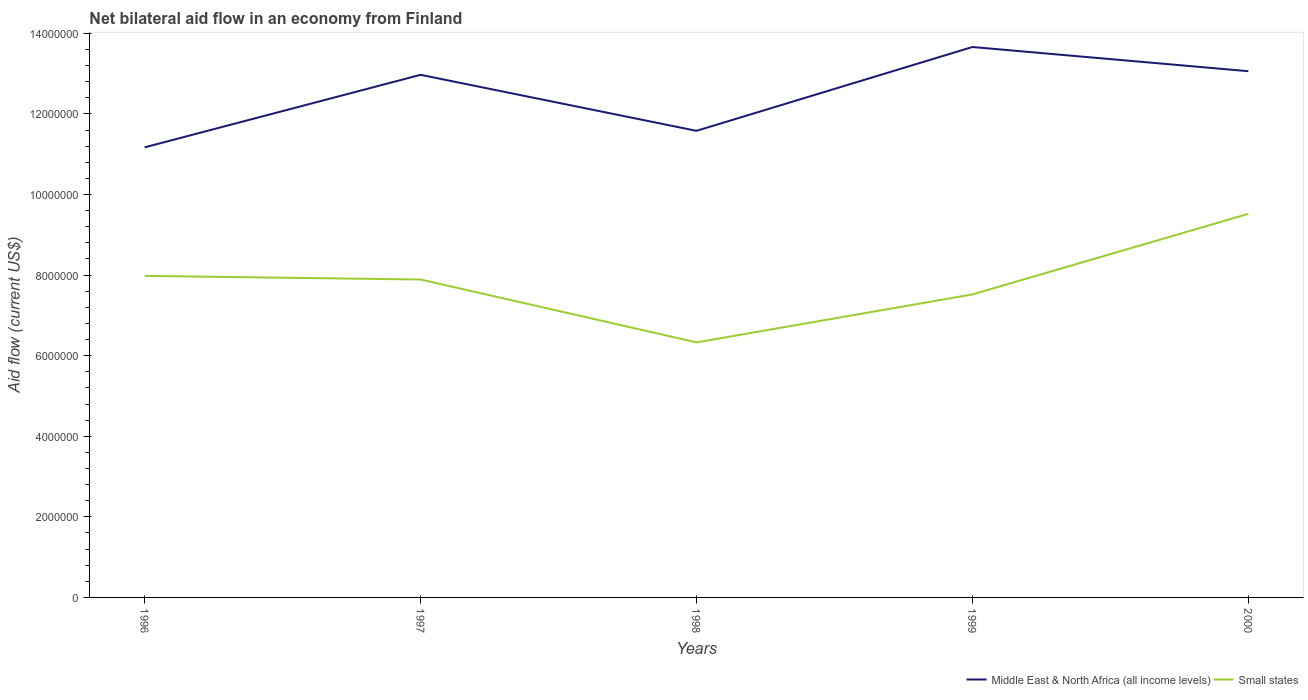Is the number of lines equal to the number of legend labels?
Keep it short and to the point. Yes. Across all years, what is the maximum net bilateral aid flow in Middle East & North Africa (all income levels)?
Make the answer very short. 1.12e+07. In which year was the net bilateral aid flow in Middle East & North Africa (all income levels) maximum?
Provide a short and direct response. 1996. What is the total net bilateral aid flow in Small states in the graph?
Your answer should be very brief. 1.56e+06. What is the difference between the highest and the second highest net bilateral aid flow in Middle East & North Africa (all income levels)?
Make the answer very short. 2.49e+06. What is the difference between the highest and the lowest net bilateral aid flow in Middle East & North Africa (all income levels)?
Offer a very short reply. 3. How many lines are there?
Give a very brief answer. 2. What is the difference between two consecutive major ticks on the Y-axis?
Give a very brief answer. 2.00e+06. Are the values on the major ticks of Y-axis written in scientific E-notation?
Your response must be concise. No. Where does the legend appear in the graph?
Ensure brevity in your answer.  Bottom right. How many legend labels are there?
Provide a short and direct response. 2. What is the title of the graph?
Provide a short and direct response. Net bilateral aid flow in an economy from Finland. Does "St. Kitts and Nevis" appear as one of the legend labels in the graph?
Ensure brevity in your answer.  No. What is the label or title of the X-axis?
Provide a succinct answer. Years. What is the label or title of the Y-axis?
Your response must be concise. Aid flow (current US$). What is the Aid flow (current US$) in Middle East & North Africa (all income levels) in 1996?
Offer a very short reply. 1.12e+07. What is the Aid flow (current US$) in Small states in 1996?
Your answer should be compact. 7.98e+06. What is the Aid flow (current US$) in Middle East & North Africa (all income levels) in 1997?
Give a very brief answer. 1.30e+07. What is the Aid flow (current US$) in Small states in 1997?
Make the answer very short. 7.89e+06. What is the Aid flow (current US$) in Middle East & North Africa (all income levels) in 1998?
Offer a terse response. 1.16e+07. What is the Aid flow (current US$) of Small states in 1998?
Offer a terse response. 6.33e+06. What is the Aid flow (current US$) in Middle East & North Africa (all income levels) in 1999?
Offer a terse response. 1.37e+07. What is the Aid flow (current US$) in Small states in 1999?
Your answer should be compact. 7.52e+06. What is the Aid flow (current US$) of Middle East & North Africa (all income levels) in 2000?
Offer a terse response. 1.31e+07. What is the Aid flow (current US$) of Small states in 2000?
Keep it short and to the point. 9.52e+06. Across all years, what is the maximum Aid flow (current US$) of Middle East & North Africa (all income levels)?
Give a very brief answer. 1.37e+07. Across all years, what is the maximum Aid flow (current US$) of Small states?
Provide a succinct answer. 9.52e+06. Across all years, what is the minimum Aid flow (current US$) in Middle East & North Africa (all income levels)?
Keep it short and to the point. 1.12e+07. Across all years, what is the minimum Aid flow (current US$) of Small states?
Your answer should be compact. 6.33e+06. What is the total Aid flow (current US$) of Middle East & North Africa (all income levels) in the graph?
Your answer should be very brief. 6.24e+07. What is the total Aid flow (current US$) of Small states in the graph?
Offer a terse response. 3.92e+07. What is the difference between the Aid flow (current US$) in Middle East & North Africa (all income levels) in 1996 and that in 1997?
Keep it short and to the point. -1.80e+06. What is the difference between the Aid flow (current US$) of Middle East & North Africa (all income levels) in 1996 and that in 1998?
Your answer should be very brief. -4.10e+05. What is the difference between the Aid flow (current US$) of Small states in 1996 and that in 1998?
Provide a succinct answer. 1.65e+06. What is the difference between the Aid flow (current US$) in Middle East & North Africa (all income levels) in 1996 and that in 1999?
Make the answer very short. -2.49e+06. What is the difference between the Aid flow (current US$) of Small states in 1996 and that in 1999?
Ensure brevity in your answer.  4.60e+05. What is the difference between the Aid flow (current US$) in Middle East & North Africa (all income levels) in 1996 and that in 2000?
Ensure brevity in your answer.  -1.89e+06. What is the difference between the Aid flow (current US$) of Small states in 1996 and that in 2000?
Your answer should be compact. -1.54e+06. What is the difference between the Aid flow (current US$) of Middle East & North Africa (all income levels) in 1997 and that in 1998?
Ensure brevity in your answer.  1.39e+06. What is the difference between the Aid flow (current US$) of Small states in 1997 and that in 1998?
Provide a succinct answer. 1.56e+06. What is the difference between the Aid flow (current US$) of Middle East & North Africa (all income levels) in 1997 and that in 1999?
Provide a succinct answer. -6.90e+05. What is the difference between the Aid flow (current US$) of Small states in 1997 and that in 1999?
Keep it short and to the point. 3.70e+05. What is the difference between the Aid flow (current US$) in Small states in 1997 and that in 2000?
Keep it short and to the point. -1.63e+06. What is the difference between the Aid flow (current US$) in Middle East & North Africa (all income levels) in 1998 and that in 1999?
Your response must be concise. -2.08e+06. What is the difference between the Aid flow (current US$) in Small states in 1998 and that in 1999?
Your response must be concise. -1.19e+06. What is the difference between the Aid flow (current US$) of Middle East & North Africa (all income levels) in 1998 and that in 2000?
Ensure brevity in your answer.  -1.48e+06. What is the difference between the Aid flow (current US$) of Small states in 1998 and that in 2000?
Your answer should be very brief. -3.19e+06. What is the difference between the Aid flow (current US$) in Small states in 1999 and that in 2000?
Provide a short and direct response. -2.00e+06. What is the difference between the Aid flow (current US$) in Middle East & North Africa (all income levels) in 1996 and the Aid flow (current US$) in Small states in 1997?
Provide a short and direct response. 3.28e+06. What is the difference between the Aid flow (current US$) of Middle East & North Africa (all income levels) in 1996 and the Aid flow (current US$) of Small states in 1998?
Provide a short and direct response. 4.84e+06. What is the difference between the Aid flow (current US$) of Middle East & North Africa (all income levels) in 1996 and the Aid flow (current US$) of Small states in 1999?
Your response must be concise. 3.65e+06. What is the difference between the Aid flow (current US$) in Middle East & North Africa (all income levels) in 1996 and the Aid flow (current US$) in Small states in 2000?
Keep it short and to the point. 1.65e+06. What is the difference between the Aid flow (current US$) in Middle East & North Africa (all income levels) in 1997 and the Aid flow (current US$) in Small states in 1998?
Provide a succinct answer. 6.64e+06. What is the difference between the Aid flow (current US$) of Middle East & North Africa (all income levels) in 1997 and the Aid flow (current US$) of Small states in 1999?
Your answer should be very brief. 5.45e+06. What is the difference between the Aid flow (current US$) of Middle East & North Africa (all income levels) in 1997 and the Aid flow (current US$) of Small states in 2000?
Provide a succinct answer. 3.45e+06. What is the difference between the Aid flow (current US$) in Middle East & North Africa (all income levels) in 1998 and the Aid flow (current US$) in Small states in 1999?
Provide a succinct answer. 4.06e+06. What is the difference between the Aid flow (current US$) in Middle East & North Africa (all income levels) in 1998 and the Aid flow (current US$) in Small states in 2000?
Make the answer very short. 2.06e+06. What is the difference between the Aid flow (current US$) of Middle East & North Africa (all income levels) in 1999 and the Aid flow (current US$) of Small states in 2000?
Keep it short and to the point. 4.14e+06. What is the average Aid flow (current US$) of Middle East & North Africa (all income levels) per year?
Offer a terse response. 1.25e+07. What is the average Aid flow (current US$) in Small states per year?
Your answer should be compact. 7.85e+06. In the year 1996, what is the difference between the Aid flow (current US$) in Middle East & North Africa (all income levels) and Aid flow (current US$) in Small states?
Give a very brief answer. 3.19e+06. In the year 1997, what is the difference between the Aid flow (current US$) in Middle East & North Africa (all income levels) and Aid flow (current US$) in Small states?
Keep it short and to the point. 5.08e+06. In the year 1998, what is the difference between the Aid flow (current US$) of Middle East & North Africa (all income levels) and Aid flow (current US$) of Small states?
Your answer should be very brief. 5.25e+06. In the year 1999, what is the difference between the Aid flow (current US$) in Middle East & North Africa (all income levels) and Aid flow (current US$) in Small states?
Keep it short and to the point. 6.14e+06. In the year 2000, what is the difference between the Aid flow (current US$) of Middle East & North Africa (all income levels) and Aid flow (current US$) of Small states?
Your answer should be compact. 3.54e+06. What is the ratio of the Aid flow (current US$) of Middle East & North Africa (all income levels) in 1996 to that in 1997?
Give a very brief answer. 0.86. What is the ratio of the Aid flow (current US$) in Small states in 1996 to that in 1997?
Your answer should be compact. 1.01. What is the ratio of the Aid flow (current US$) in Middle East & North Africa (all income levels) in 1996 to that in 1998?
Give a very brief answer. 0.96. What is the ratio of the Aid flow (current US$) of Small states in 1996 to that in 1998?
Give a very brief answer. 1.26. What is the ratio of the Aid flow (current US$) of Middle East & North Africa (all income levels) in 1996 to that in 1999?
Offer a terse response. 0.82. What is the ratio of the Aid flow (current US$) of Small states in 1996 to that in 1999?
Your answer should be compact. 1.06. What is the ratio of the Aid flow (current US$) in Middle East & North Africa (all income levels) in 1996 to that in 2000?
Offer a terse response. 0.86. What is the ratio of the Aid flow (current US$) in Small states in 1996 to that in 2000?
Make the answer very short. 0.84. What is the ratio of the Aid flow (current US$) of Middle East & North Africa (all income levels) in 1997 to that in 1998?
Provide a short and direct response. 1.12. What is the ratio of the Aid flow (current US$) in Small states in 1997 to that in 1998?
Keep it short and to the point. 1.25. What is the ratio of the Aid flow (current US$) in Middle East & North Africa (all income levels) in 1997 to that in 1999?
Keep it short and to the point. 0.95. What is the ratio of the Aid flow (current US$) of Small states in 1997 to that in 1999?
Your answer should be very brief. 1.05. What is the ratio of the Aid flow (current US$) in Middle East & North Africa (all income levels) in 1997 to that in 2000?
Your answer should be very brief. 0.99. What is the ratio of the Aid flow (current US$) in Small states in 1997 to that in 2000?
Offer a very short reply. 0.83. What is the ratio of the Aid flow (current US$) in Middle East & North Africa (all income levels) in 1998 to that in 1999?
Your answer should be compact. 0.85. What is the ratio of the Aid flow (current US$) in Small states in 1998 to that in 1999?
Your answer should be compact. 0.84. What is the ratio of the Aid flow (current US$) of Middle East & North Africa (all income levels) in 1998 to that in 2000?
Offer a very short reply. 0.89. What is the ratio of the Aid flow (current US$) of Small states in 1998 to that in 2000?
Your response must be concise. 0.66. What is the ratio of the Aid flow (current US$) of Middle East & North Africa (all income levels) in 1999 to that in 2000?
Your answer should be very brief. 1.05. What is the ratio of the Aid flow (current US$) in Small states in 1999 to that in 2000?
Make the answer very short. 0.79. What is the difference between the highest and the second highest Aid flow (current US$) in Small states?
Provide a succinct answer. 1.54e+06. What is the difference between the highest and the lowest Aid flow (current US$) of Middle East & North Africa (all income levels)?
Make the answer very short. 2.49e+06. What is the difference between the highest and the lowest Aid flow (current US$) in Small states?
Provide a succinct answer. 3.19e+06. 